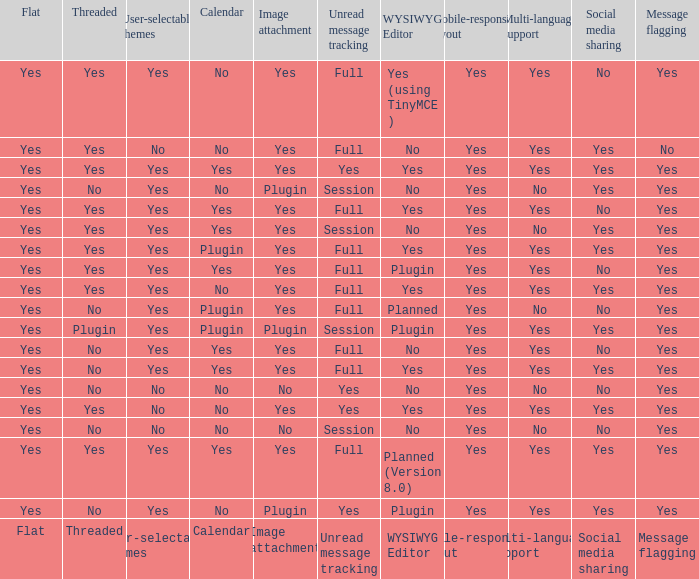Which wysiwyg editor possesses an image attachment capability and a calendar extension? Yes, Planned. 